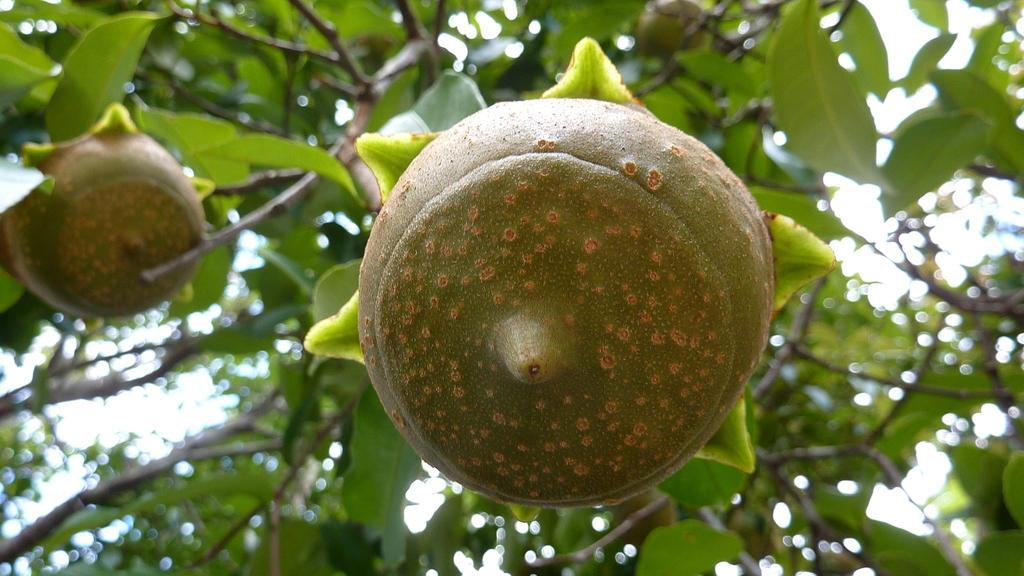What type of food items can be seen in the image? There are fruits in the image. What other living organisms are present in the image? There are plants in the image. What brand of toothpaste is visible in the image? There is no toothpaste present in the image. What type of lock can be seen securing the plants in the image? There is no lock present in the image; the plants are not secured. 